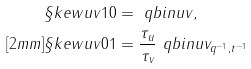Convert formula to latex. <formula><loc_0><loc_0><loc_500><loc_500>\S k e w { u } { v } { 1 } { 0 } & = \ q b i n { u } { v } , \\ [ 2 m m ] \S k e w { u } { v } { 0 } { 1 } & = \frac { \tau _ { u } } { \tau _ { v } } \ q b i n { u } { v } _ { q ^ { - 1 } , t ^ { - 1 } }</formula> 